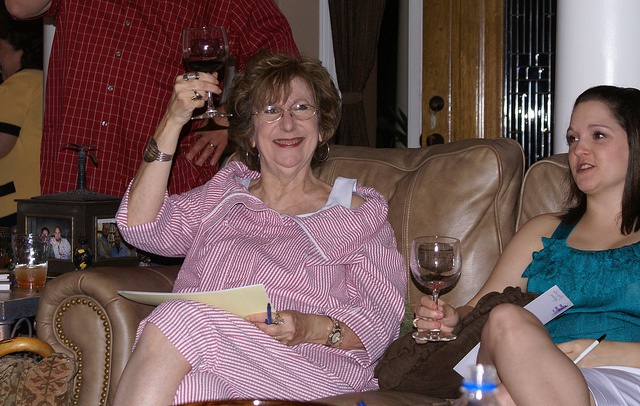Describe the objects in this image and their specific colors. I can see people in black, brown, darkgray, gray, and lavender tones, people in black, gray, darkgray, and blue tones, people in black, maroon, and brown tones, couch in black, gray, and maroon tones, and people in black, brown, maroon, and olive tones in this image. 